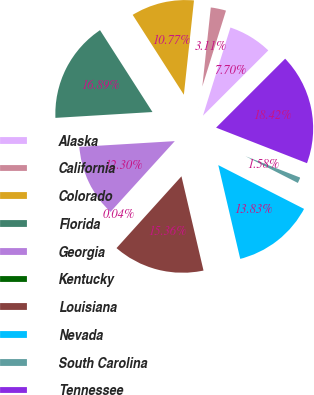<chart> <loc_0><loc_0><loc_500><loc_500><pie_chart><fcel>Alaska<fcel>California<fcel>Colorado<fcel>Florida<fcel>Georgia<fcel>Kentucky<fcel>Louisiana<fcel>Nevada<fcel>South Carolina<fcel>Tennessee<nl><fcel>7.7%<fcel>3.11%<fcel>10.77%<fcel>16.89%<fcel>12.3%<fcel>0.04%<fcel>15.36%<fcel>13.83%<fcel>1.58%<fcel>18.42%<nl></chart> 